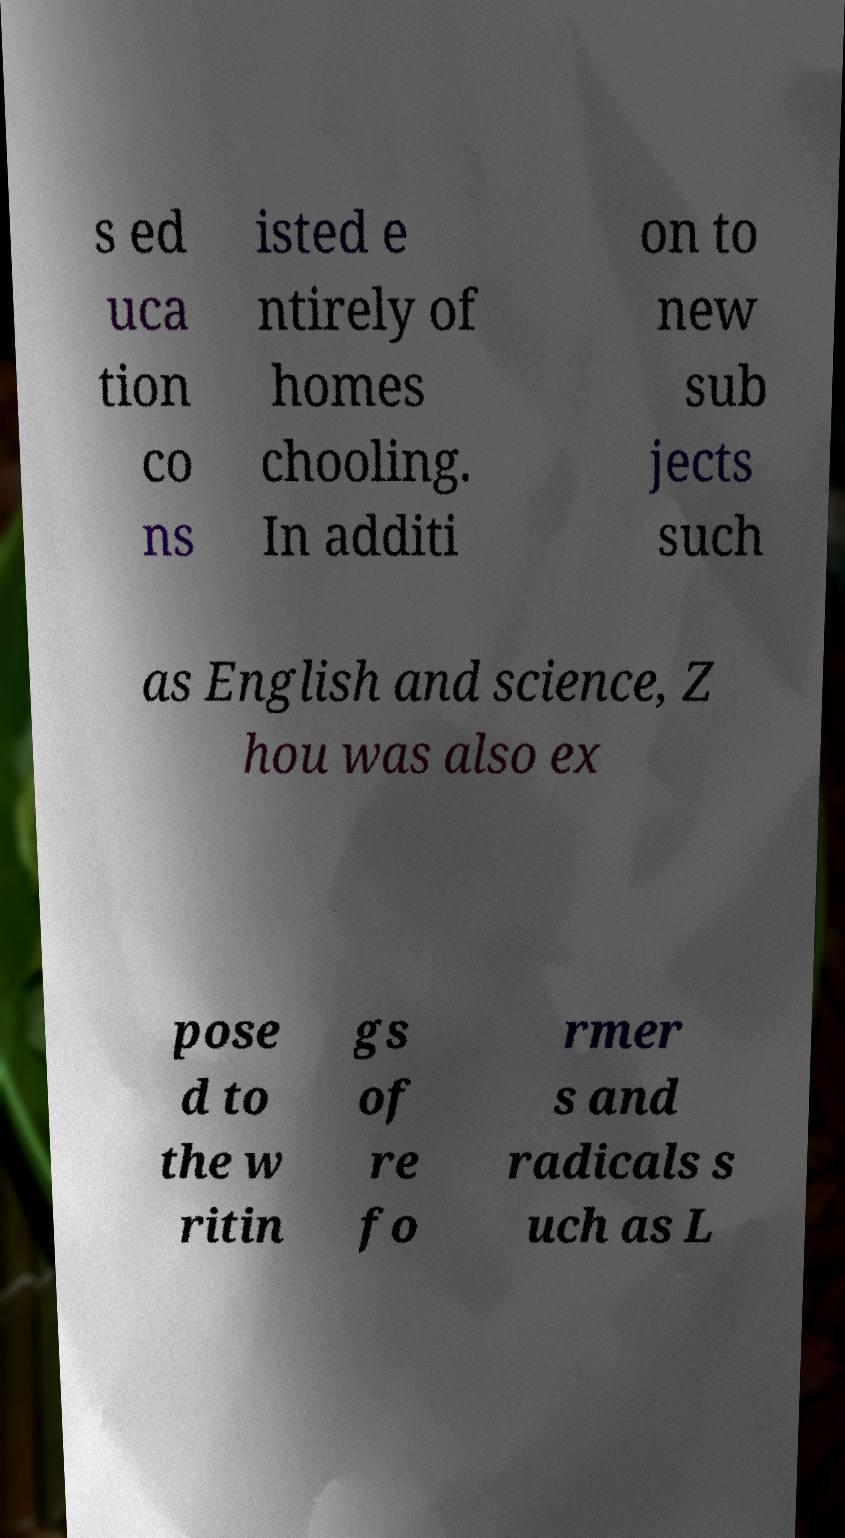Please identify and transcribe the text found in this image. s ed uca tion co ns isted e ntirely of homes chooling. In additi on to new sub jects such as English and science, Z hou was also ex pose d to the w ritin gs of re fo rmer s and radicals s uch as L 